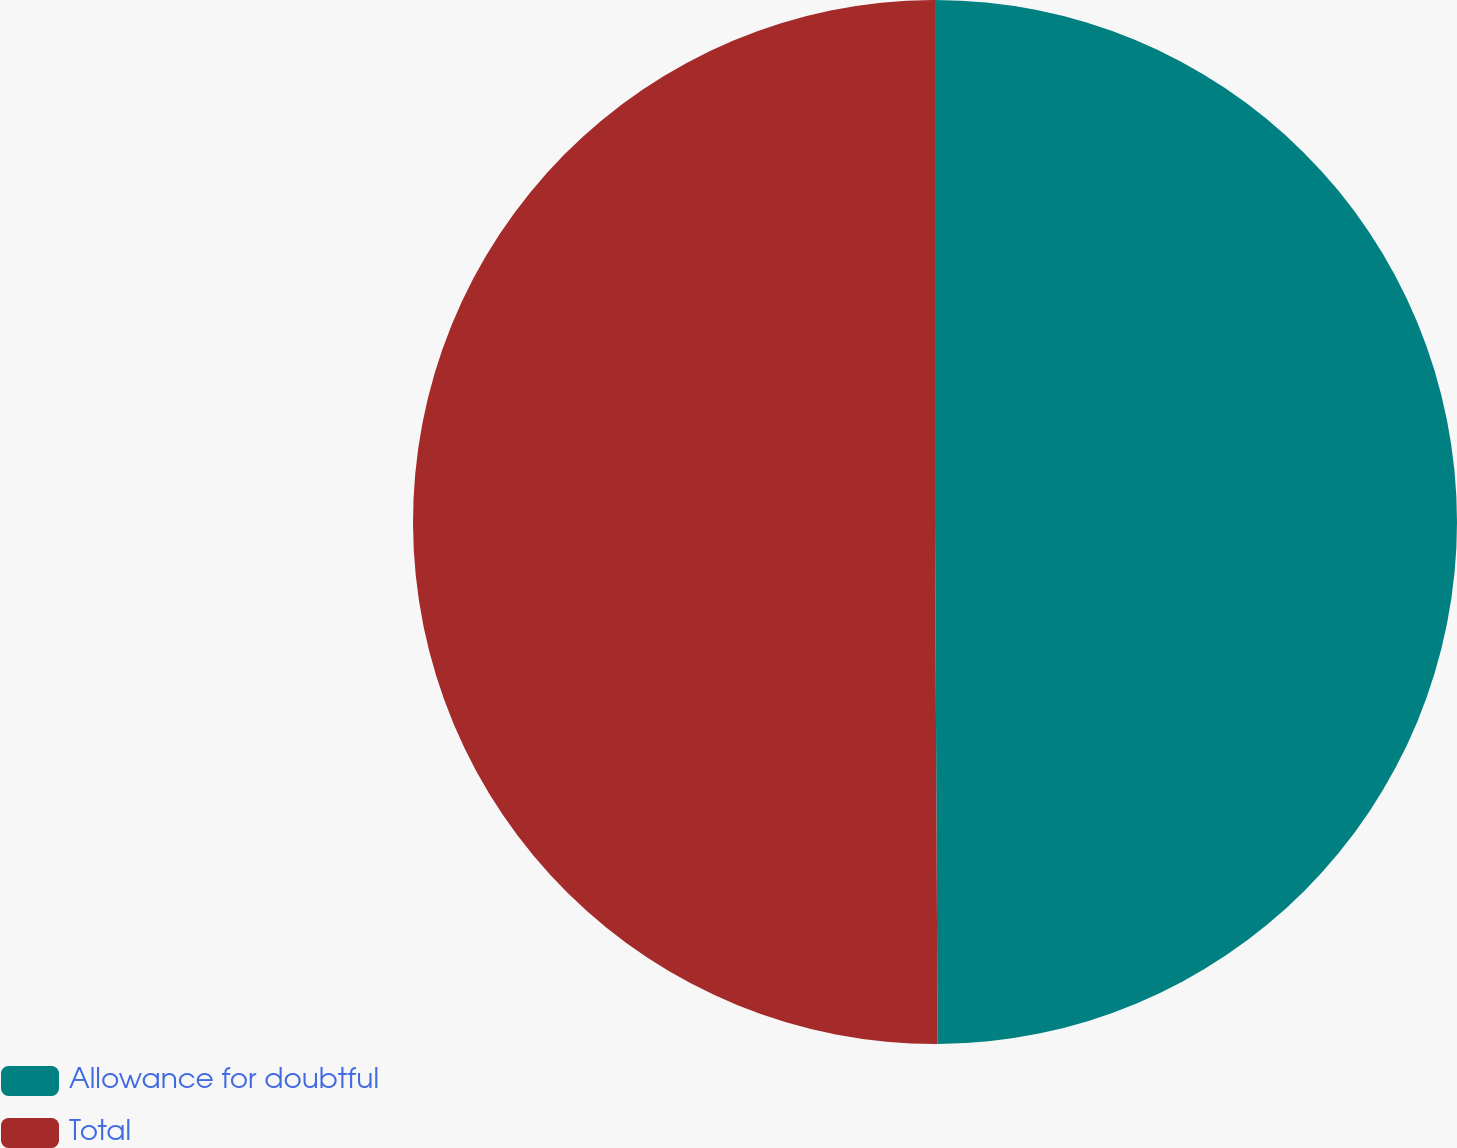Convert chart to OTSL. <chart><loc_0><loc_0><loc_500><loc_500><pie_chart><fcel>Allowance for doubtful<fcel>Total<nl><fcel>49.92%<fcel>50.08%<nl></chart> 